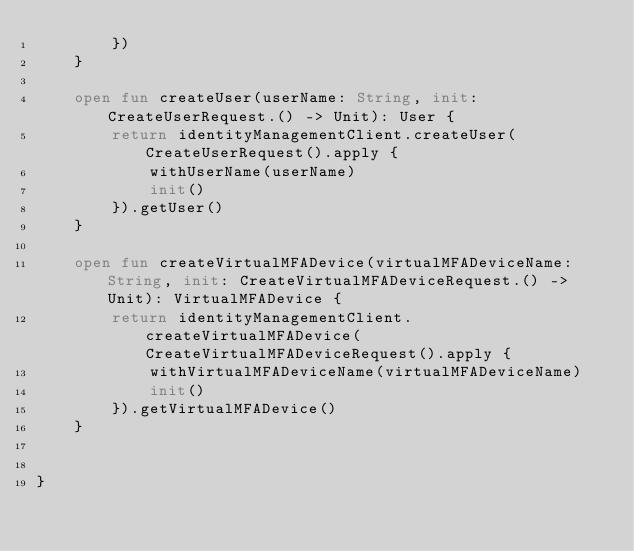<code> <loc_0><loc_0><loc_500><loc_500><_Kotlin_>        })
    }

    open fun createUser(userName: String, init: CreateUserRequest.() -> Unit): User {
        return identityManagementClient.createUser(CreateUserRequest().apply {
            withUserName(userName)
            init()
        }).getUser()
    }

    open fun createVirtualMFADevice(virtualMFADeviceName: String, init: CreateVirtualMFADeviceRequest.() -> Unit): VirtualMFADevice {
        return identityManagementClient.createVirtualMFADevice(CreateVirtualMFADeviceRequest().apply {
            withVirtualMFADeviceName(virtualMFADeviceName)
            init()
        }).getVirtualMFADevice()
    }


}

</code> 